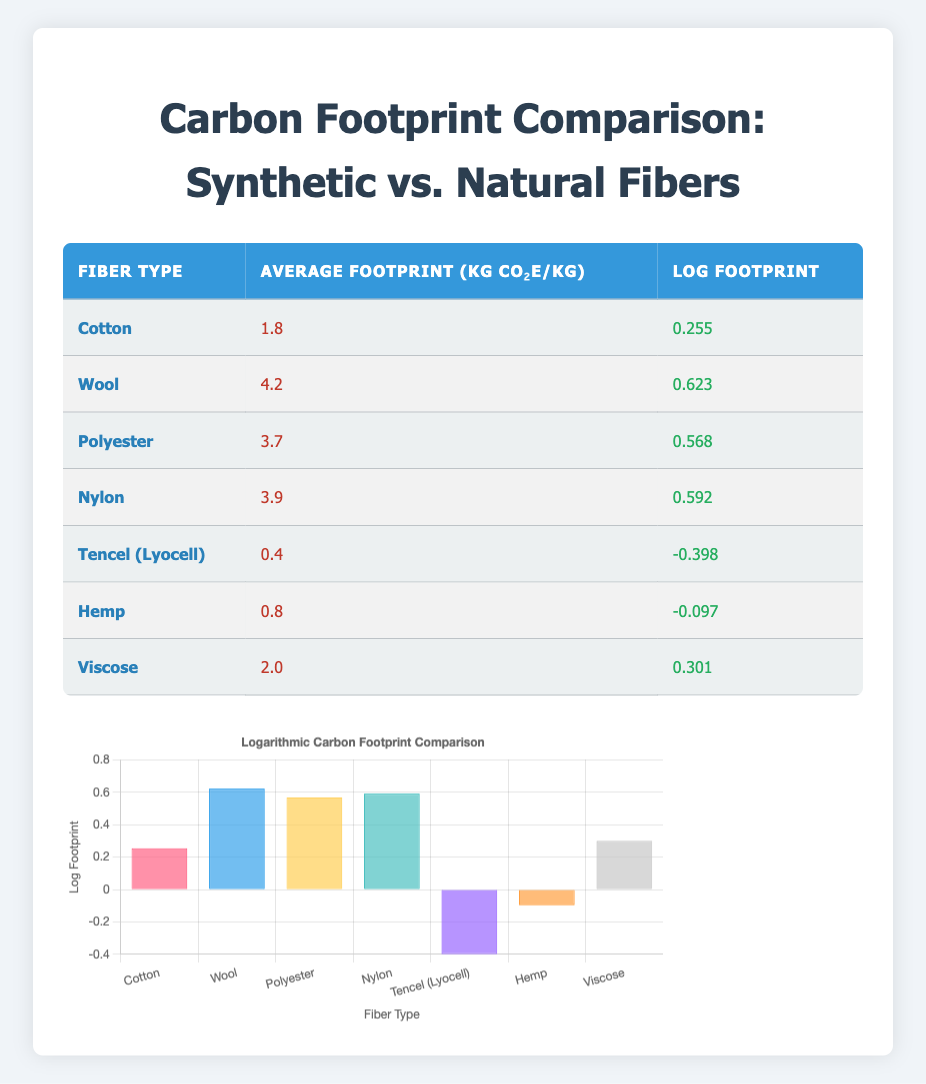What is the average carbon footprint per kg for Cotton? The carbon footprint value for Cotton is clearly listed in the table as 1.8 kg CO₂e/kg.
Answer: 1.8 kg CO₂e/kg Which fiber has the highest average carbon footprint? By checking the average footprint values in the table, Wool has the highest value at 4.2 kg CO₂e/kg.
Answer: Wool What is the log footprint value for Tencel (Lyocell)? The log footprint value for Tencel (Lyocell) is indicated as -0.398 in the corresponding row.
Answer: -0.398 What is the total average footprint of all the synthetic fibers mentioned? The synthetic fibers listed are Polyester (3.7), Nylon (3.9). Adding these values gives 3.7 + 3.9 = 7.6 kg CO₂e/kg.
Answer: 7.6 kg CO₂e/kg Is the average carbon footprint of Hemp greater than that of Tencel (Lyocell)? The average footprint for Hemp is 0.8 kg CO₂e/kg, while Tencel (Lyocell) is 0.4 kg CO₂e/kg. Since 0.8 > 0.4, the statement is true.
Answer: Yes What is the difference between the highest and lowest average carbon footprints? The highest average footprint is Wool at 4.2 kg CO₂e/kg, and the lowest is Tencel (Lyocell) at 0.4 kg CO₂e/kg. The difference is 4.2 - 0.4 = 3.8 kg CO₂e/kg.
Answer: 3.8 kg CO₂e/kg How many fibers have an average footprint below 1 kg CO₂e/kg? The fibers below 1 kg CO₂e/kg are Tencel (0.4) and Hemp (0.8), totaling 2 fibers.
Answer: 2 Which fiber types have a log footprint greater than 0.5? The fibers Wool (0.623), Polyester (0.568), and Nylon (0.592) each have log footprint values greater than 0.5.
Answer: Wool, Polyester, Nylon What is the average carbon footprint of natural fibers? The natural fibers listed are Cotton (1.8), Wool (4.2), Tencel (0.4), Hemp (0.8), and Viscose (2.0). The total average is (1.8 + 4.2 + 0.4 + 0.8 + 2.0) / 5 = 1.84 kg CO₂e/kg.
Answer: 1.84 kg CO₂e/kg 